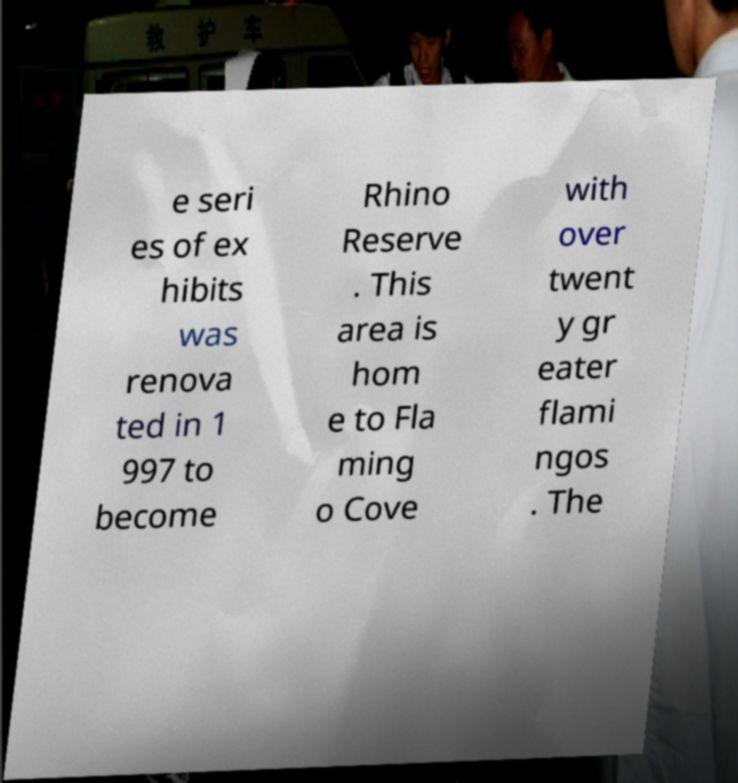Please identify and transcribe the text found in this image. e seri es of ex hibits was renova ted in 1 997 to become Rhino Reserve . This area is hom e to Fla ming o Cove with over twent y gr eater flami ngos . The 